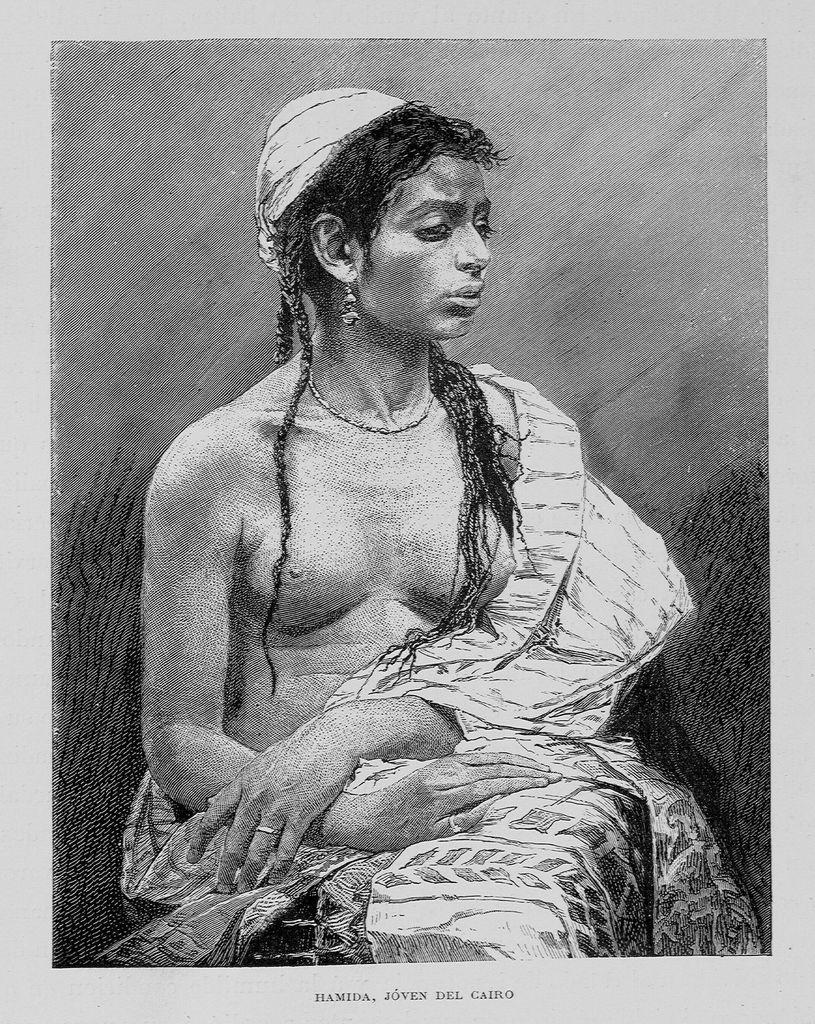What is the color scheme of the image? The image is black and white. Who or what is the main subject in the image? There is a woman in the image. What is the woman doing in the image? The woman is sitting on a chair. Is there any text present in the image? Yes, there is text at the bottom of the image. What type of toothpaste is the woman using in the image? There is no toothpaste present in the image. Can you hear the woman's voice in the image? The image is a still photograph, so there is no sound or voice present. 